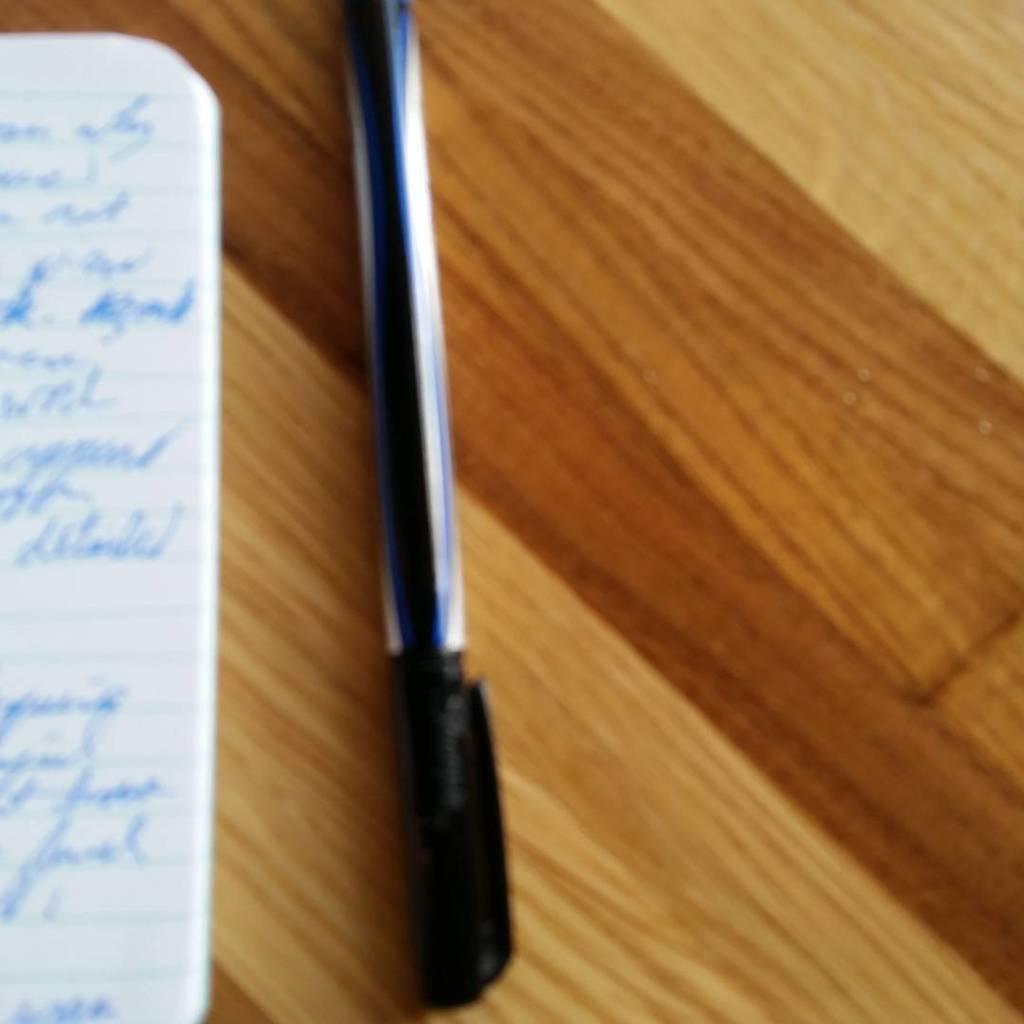Could you give a brief overview of what you see in this image? In this image I can see the paper and pen on the brown color table. The paper is in white color and the pen is in black color. 